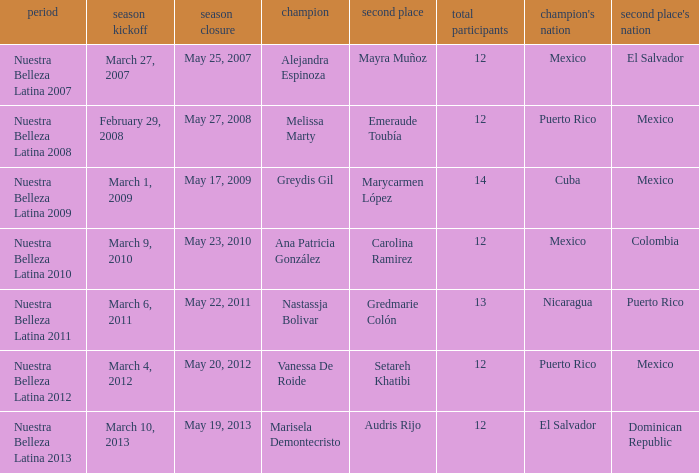How many contestants were there in a season where alejandra espinoza won? 1.0. 